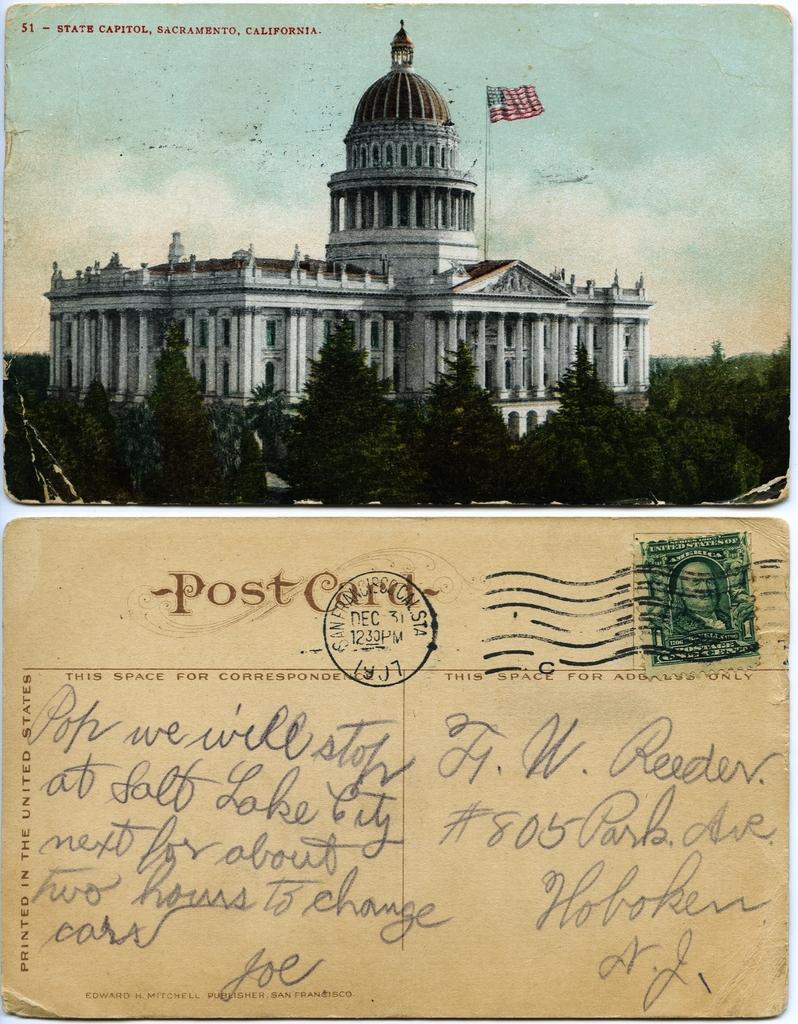What type of image is being described? The image is a collage. What can be seen at the top of the collage? There is a building, trees, a flag, and the sky visible at the top of the image. What is located at the bottom of the collage? There is a postcard at the bottom of the image. Does the postcard have a stamp? No, the postcard does not have a stamp. What is written or printed on the postcard? There is text on the postcard. Where is the toothpaste located in the image? There is no toothpaste present in the image. What type of exchange is taking place between the building and the trees in the image? There is no exchange between the building and the trees in the image; they are separate elements within the collage. 